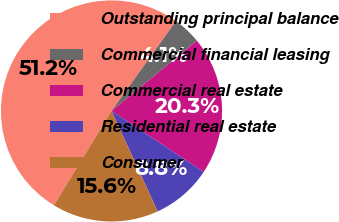Convert chart. <chart><loc_0><loc_0><loc_500><loc_500><pie_chart><fcel>Outstanding principal balance<fcel>Commercial financial leasing<fcel>Commercial real estate<fcel>Residential real estate<fcel>Consumer<nl><fcel>51.19%<fcel>4.13%<fcel>20.27%<fcel>8.84%<fcel>15.57%<nl></chart> 